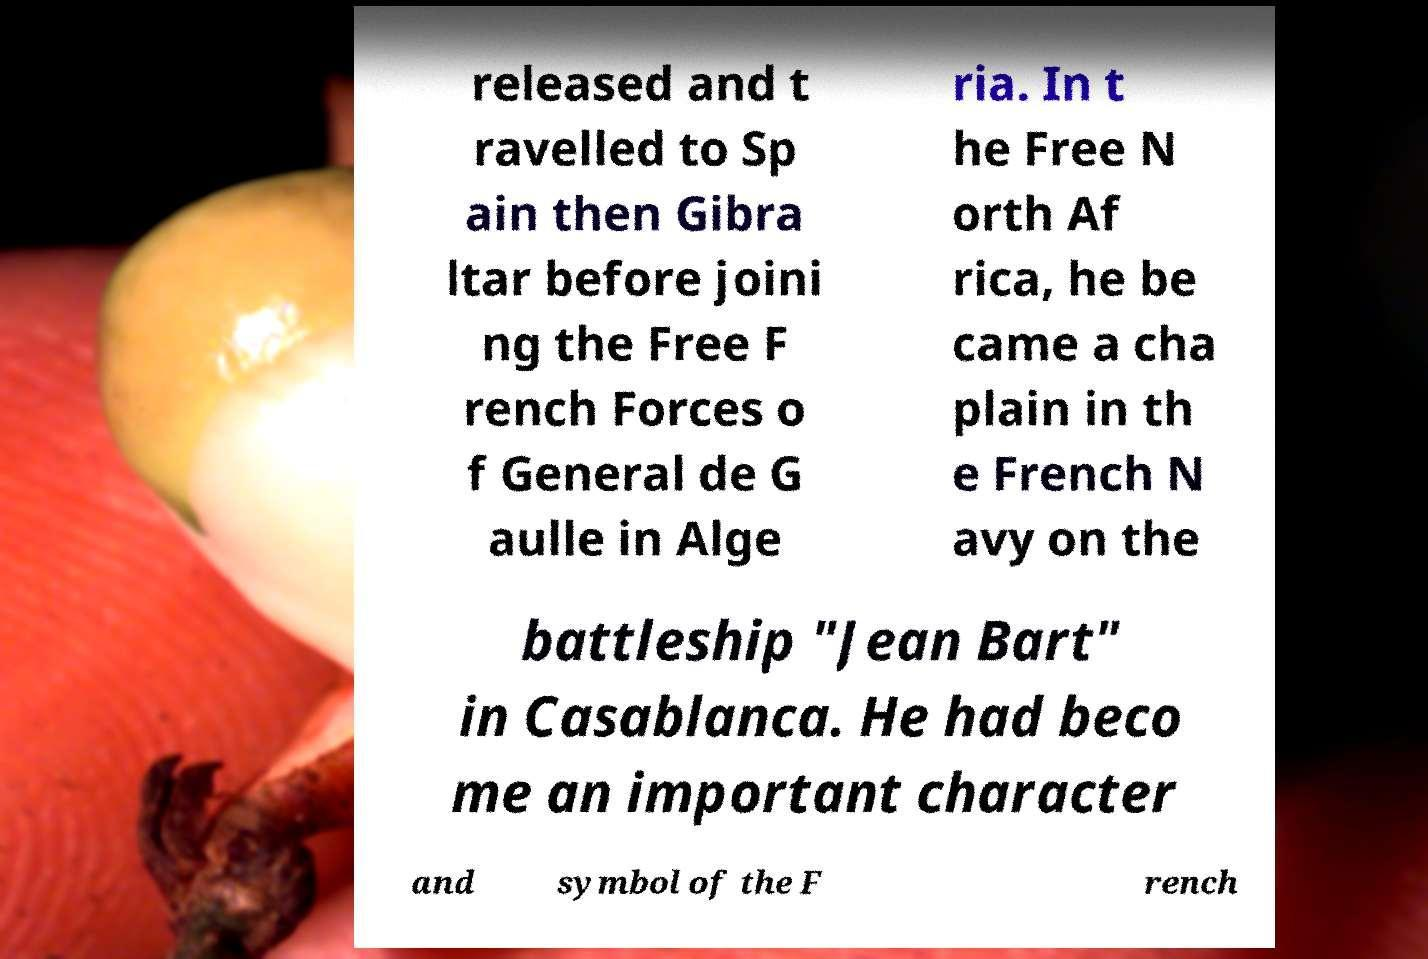For documentation purposes, I need the text within this image transcribed. Could you provide that? released and t ravelled to Sp ain then Gibra ltar before joini ng the Free F rench Forces o f General de G aulle in Alge ria. In t he Free N orth Af rica, he be came a cha plain in th e French N avy on the battleship "Jean Bart" in Casablanca. He had beco me an important character and symbol of the F rench 